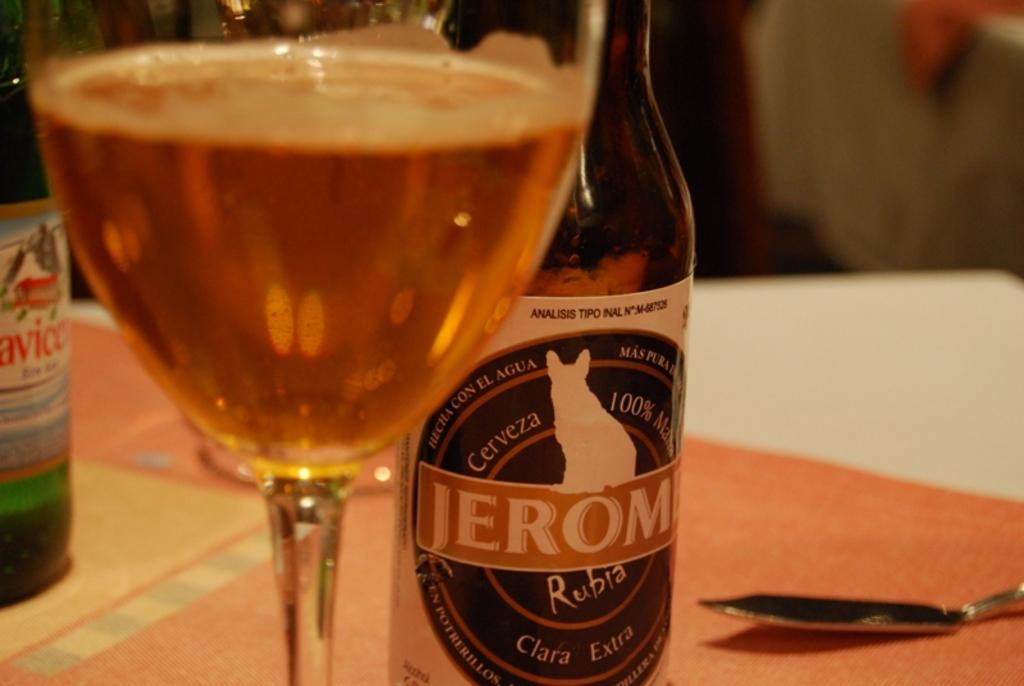<image>
Present a compact description of the photo's key features. A glass filled with alcohol is on the table in front of two bottles and a spoon. 